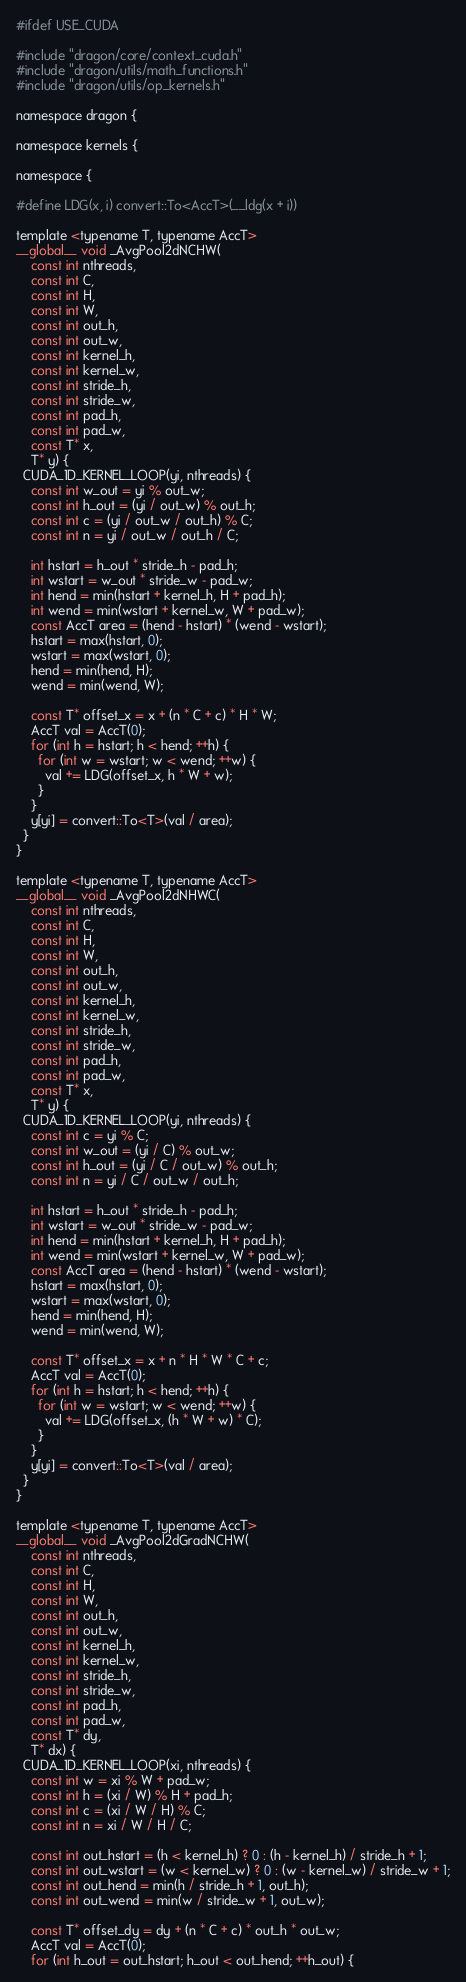Convert code to text. <code><loc_0><loc_0><loc_500><loc_500><_Cuda_>#ifdef USE_CUDA

#include "dragon/core/context_cuda.h"
#include "dragon/utils/math_functions.h"
#include "dragon/utils/op_kernels.h"

namespace dragon {

namespace kernels {

namespace {

#define LDG(x, i) convert::To<AccT>(__ldg(x + i))

template <typename T, typename AccT>
__global__ void _AvgPool2dNCHW(
    const int nthreads,
    const int C,
    const int H,
    const int W,
    const int out_h,
    const int out_w,
    const int kernel_h,
    const int kernel_w,
    const int stride_h,
    const int stride_w,
    const int pad_h,
    const int pad_w,
    const T* x,
    T* y) {
  CUDA_1D_KERNEL_LOOP(yi, nthreads) {
    const int w_out = yi % out_w;
    const int h_out = (yi / out_w) % out_h;
    const int c = (yi / out_w / out_h) % C;
    const int n = yi / out_w / out_h / C;

    int hstart = h_out * stride_h - pad_h;
    int wstart = w_out * stride_w - pad_w;
    int hend = min(hstart + kernel_h, H + pad_h);
    int wend = min(wstart + kernel_w, W + pad_w);
    const AccT area = (hend - hstart) * (wend - wstart);
    hstart = max(hstart, 0);
    wstart = max(wstart, 0);
    hend = min(hend, H);
    wend = min(wend, W);

    const T* offset_x = x + (n * C + c) * H * W;
    AccT val = AccT(0);
    for (int h = hstart; h < hend; ++h) {
      for (int w = wstart; w < wend; ++w) {
        val += LDG(offset_x, h * W + w);
      }
    }
    y[yi] = convert::To<T>(val / area);
  }
}

template <typename T, typename AccT>
__global__ void _AvgPool2dNHWC(
    const int nthreads,
    const int C,
    const int H,
    const int W,
    const int out_h,
    const int out_w,
    const int kernel_h,
    const int kernel_w,
    const int stride_h,
    const int stride_w,
    const int pad_h,
    const int pad_w,
    const T* x,
    T* y) {
  CUDA_1D_KERNEL_LOOP(yi, nthreads) {
    const int c = yi % C;
    const int w_out = (yi / C) % out_w;
    const int h_out = (yi / C / out_w) % out_h;
    const int n = yi / C / out_w / out_h;

    int hstart = h_out * stride_h - pad_h;
    int wstart = w_out * stride_w - pad_w;
    int hend = min(hstart + kernel_h, H + pad_h);
    int wend = min(wstart + kernel_w, W + pad_w);
    const AccT area = (hend - hstart) * (wend - wstart);
    hstart = max(hstart, 0);
    wstart = max(wstart, 0);
    hend = min(hend, H);
    wend = min(wend, W);

    const T* offset_x = x + n * H * W * C + c;
    AccT val = AccT(0);
    for (int h = hstart; h < hend; ++h) {
      for (int w = wstart; w < wend; ++w) {
        val += LDG(offset_x, (h * W + w) * C);
      }
    }
    y[yi] = convert::To<T>(val / area);
  }
}

template <typename T, typename AccT>
__global__ void _AvgPool2dGradNCHW(
    const int nthreads,
    const int C,
    const int H,
    const int W,
    const int out_h,
    const int out_w,
    const int kernel_h,
    const int kernel_w,
    const int stride_h,
    const int stride_w,
    const int pad_h,
    const int pad_w,
    const T* dy,
    T* dx) {
  CUDA_1D_KERNEL_LOOP(xi, nthreads) {
    const int w = xi % W + pad_w;
    const int h = (xi / W) % H + pad_h;
    const int c = (xi / W / H) % C;
    const int n = xi / W / H / C;

    const int out_hstart = (h < kernel_h) ? 0 : (h - kernel_h) / stride_h + 1;
    const int out_wstart = (w < kernel_w) ? 0 : (w - kernel_w) / stride_w + 1;
    const int out_hend = min(h / stride_h + 1, out_h);
    const int out_wend = min(w / stride_w + 1, out_w);

    const T* offset_dy = dy + (n * C + c) * out_h * out_w;
    AccT val = AccT(0);
    for (int h_out = out_hstart; h_out < out_hend; ++h_out) {</code> 